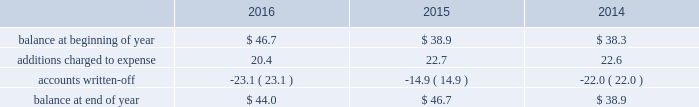Republic services , inc .
Notes to consolidated financial statements 2014 ( continued ) high quality financial institutions .
Such balances may be in excess of fdic insured limits .
To manage the related credit exposure , we continually monitor the credit worthiness of the financial institutions where we have deposits .
Concentrations of credit risk with respect to trade accounts receivable are limited due to the wide variety of customers and markets in which we provide services , as well as the dispersion of our operations across many geographic areas .
We provide services to small-container commercial , large-container industrial , municipal and residential customers in the united states and puerto rico .
We perform ongoing credit evaluations of our customers , but generally do not require collateral to support customer receivables .
We establish an allowance for doubtful accounts based on various factors including the credit risk of specific customers , age of receivables outstanding , historical trends , economic conditions and other information .
Accounts receivable , net accounts receivable represent receivables from customers for collection , transfer , recycling , disposal , energy services and other services .
Our receivables are recorded when billed or when the related revenue is earned , if earlier , and represent claims against third parties that will be settled in cash .
The carrying value of our receivables , net of the allowance for doubtful accounts and customer credits , represents their estimated net realizable value .
Provisions for doubtful accounts are evaluated on a monthly basis and are recorded based on our historical collection experience , the age of the receivables , specific customer information and economic conditions .
We also review outstanding balances on an account-specific basis .
In general , reserves are provided for accounts receivable in excess of 90 days outstanding .
Past due receivable balances are written-off when our collection efforts have been unsuccessful in collecting amounts due .
The table reflects the activity in our allowance for doubtful accounts for the years ended december 31: .
Restricted cash and marketable securities as of december 31 , 2016 , we had $ 90.5 million of restricted cash and marketable securities of which $ 62.6 million supports our insurance programs for workers 2019 compensation , commercial general liability , and commercial auto liability .
Additionally , we obtain funds through the issuance of tax-exempt bonds for the purpose of financing qualifying expenditures at our landfills , transfer stations , collection and recycling centers .
The funds are deposited directly into trust accounts by the bonding authorities at the time of issuance .
As the use of these funds is contractually restricted , and we do not have the ability to use these funds for general operating purposes , they are classified as restricted cash and marketable securities in our consolidated balance sheets .
In the normal course of business , we may be required to provide financial assurance to governmental agencies and a variety of other entities in connection with municipal residential collection contracts , closure or post- closure of landfills , environmental remediation , environmental permits , and business licenses and permits as a financial guarantee of our performance .
At several of our landfills , we satisfy financial assurance requirements by depositing cash into restricted trust funds or escrow accounts .
Property and equipment we record property and equipment at cost .
Expenditures for major additions and improvements to facilities are capitalized , while maintenance and repairs are charged to expense as incurred .
When property is retired or .
As part of the restricted cash and marketable securities as of december 31 , 2016 what was the percent of the supports our insurance programs for workers 2019 compensation , commercial general liability as part of the total restricted cash and marketable securities? 
Computations: (62.6 / 90.5)
Answer: 0.69171. 